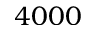Convert formula to latex. <formula><loc_0><loc_0><loc_500><loc_500>4 0 0 0</formula> 